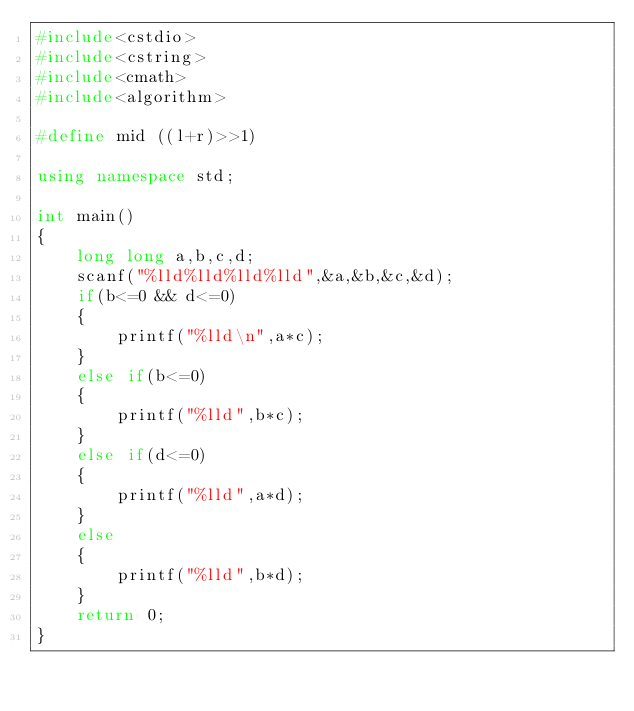Convert code to text. <code><loc_0><loc_0><loc_500><loc_500><_C++_>#include<cstdio>
#include<cstring>
#include<cmath>
#include<algorithm>

#define mid ((l+r)>>1)

using namespace std;

int main()
{
	long long a,b,c,d;
	scanf("%lld%lld%lld%lld",&a,&b,&c,&d);
	if(b<=0 && d<=0)
	{
		printf("%lld\n",a*c);
	}
	else if(b<=0)
	{
		printf("%lld",b*c);
	}
	else if(d<=0)
	{
		printf("%lld",a*d);
	}
	else
	{
		printf("%lld",b*d);
	}
	return 0;
}</code> 